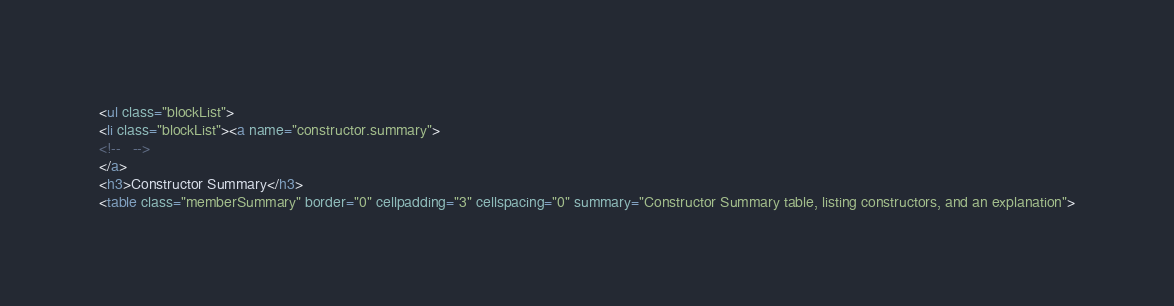Convert code to text. <code><loc_0><loc_0><loc_500><loc_500><_HTML_><ul class="blockList">
<li class="blockList"><a name="constructor.summary">
<!--   -->
</a>
<h3>Constructor Summary</h3>
<table class="memberSummary" border="0" cellpadding="3" cellspacing="0" summary="Constructor Summary table, listing constructors, and an explanation"></code> 